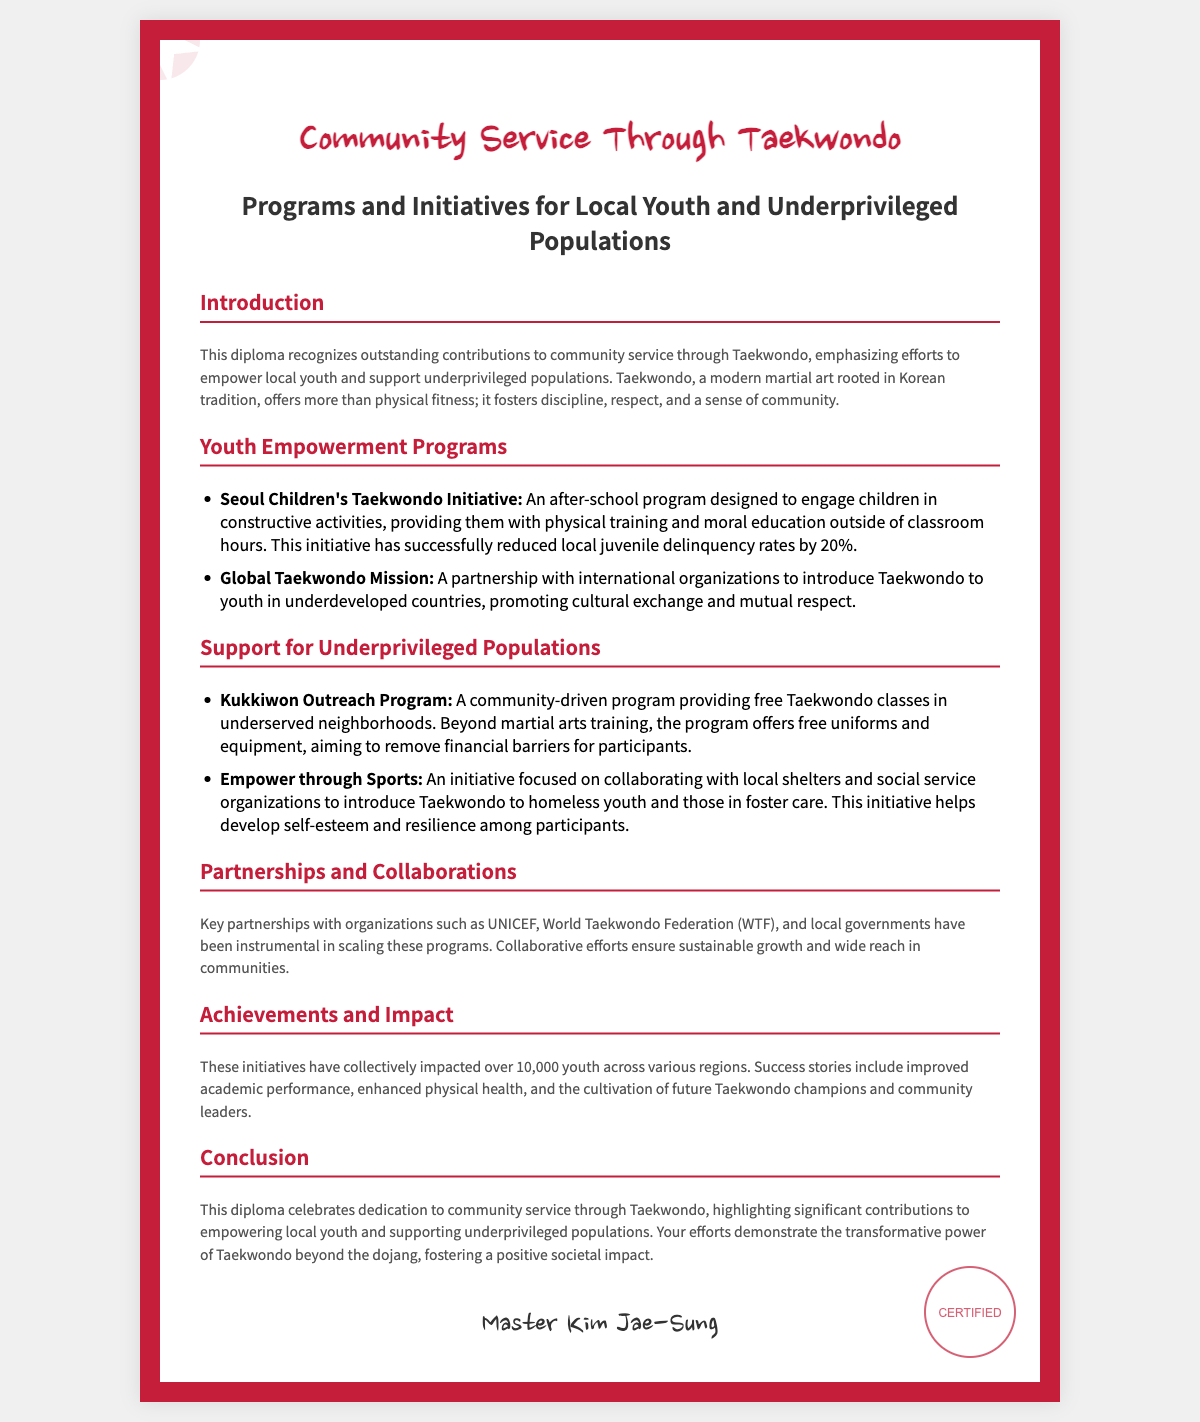what is the title of the diploma? The title is prominently displayed at the top of the document, recognizing contributions to community service through Taekwondo.
Answer: Community Service Through Taekwondo who is the author of the diploma? The author's name appears at the bottom, indicating who is issuing the diploma.
Answer: Master Kim Jae-Sung what is one of the youth empowerment programs mentioned? The document lists various youth empowerment programs under a specific header.
Answer: Seoul Children's Taekwondo Initiative how much did juvenile delinquency rates decrease by? The decrease in local juvenile delinquency rates is mentioned in the description of a specific program.
Answer: 20% what is the primary goal of the Kukkiwon Outreach Program? The goal of the program is outlined in the section about support for underprivileged populations.
Answer: Providing free Taekwondo classes how many youth have been impacted by the initiatives collectively? The document summarizes the total impact in the achievements and impact section.
Answer: Over 10,000 youth which organizations are key partners in the programs? Key partnerships are listed in the section about partnerships and collaborations.
Answer: UNICEF, World Taekwondo Federation, local governments what is emphasized as the transformative power of Taekwondo? The final section discusses the impact of Taekwondo beyond its practice.
Answer: Community service what is the main focus of the Empower through Sports initiative? The focus of the initiative is described in the support for underprivileged populations section.
Answer: Collaborating with local shelters and social service organizations 